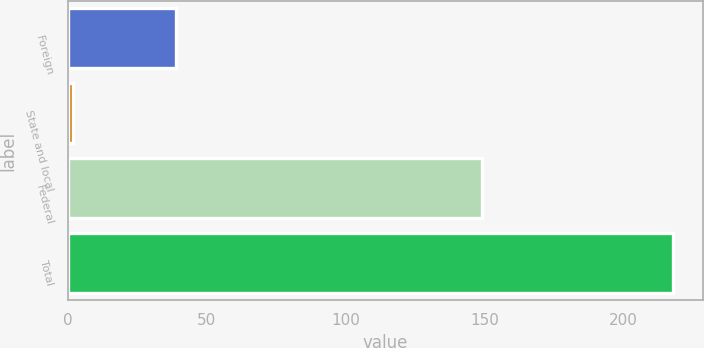Convert chart. <chart><loc_0><loc_0><loc_500><loc_500><bar_chart><fcel>Foreign<fcel>State and local<fcel>Federal<fcel>Total<nl><fcel>39<fcel>2<fcel>149<fcel>218<nl></chart> 